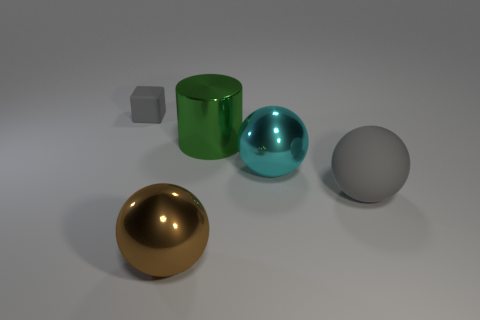What can you tell me about the lighting and its effect on the objects? The lighting in the image appears to be soft and diffused, coming predominantly from above, creating gentle shadows beneath each object. The reflective surfaces of the golden sphere and the light blue sphere are producing specular highlights, emphasizing their glossiness. In contrast, the matte surfaces of the gray cubes and gray sphere show subdued reflections and softer, less defined shadows, presenting a stark difference in texture and material quality when compared to the shiny objects. 